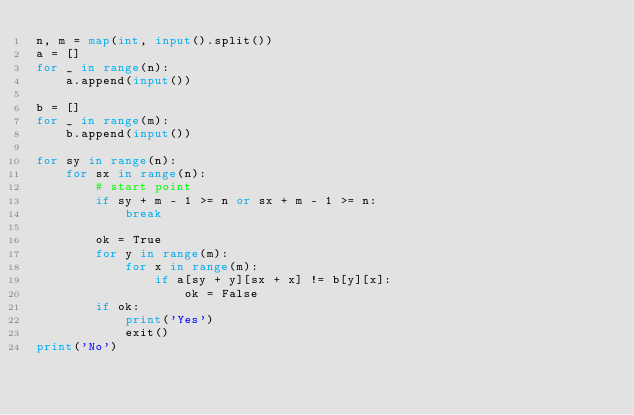Convert code to text. <code><loc_0><loc_0><loc_500><loc_500><_Python_>n, m = map(int, input().split())
a = []
for _ in range(n):
    a.append(input())

b = []
for _ in range(m):
    b.append(input())

for sy in range(n):
    for sx in range(n):
        # start point
        if sy + m - 1 >= n or sx + m - 1 >= n:
            break

        ok = True
        for y in range(m):
            for x in range(m):
                if a[sy + y][sx + x] != b[y][x]:
                    ok = False
        if ok:
            print('Yes')
            exit()
print('No')
</code> 